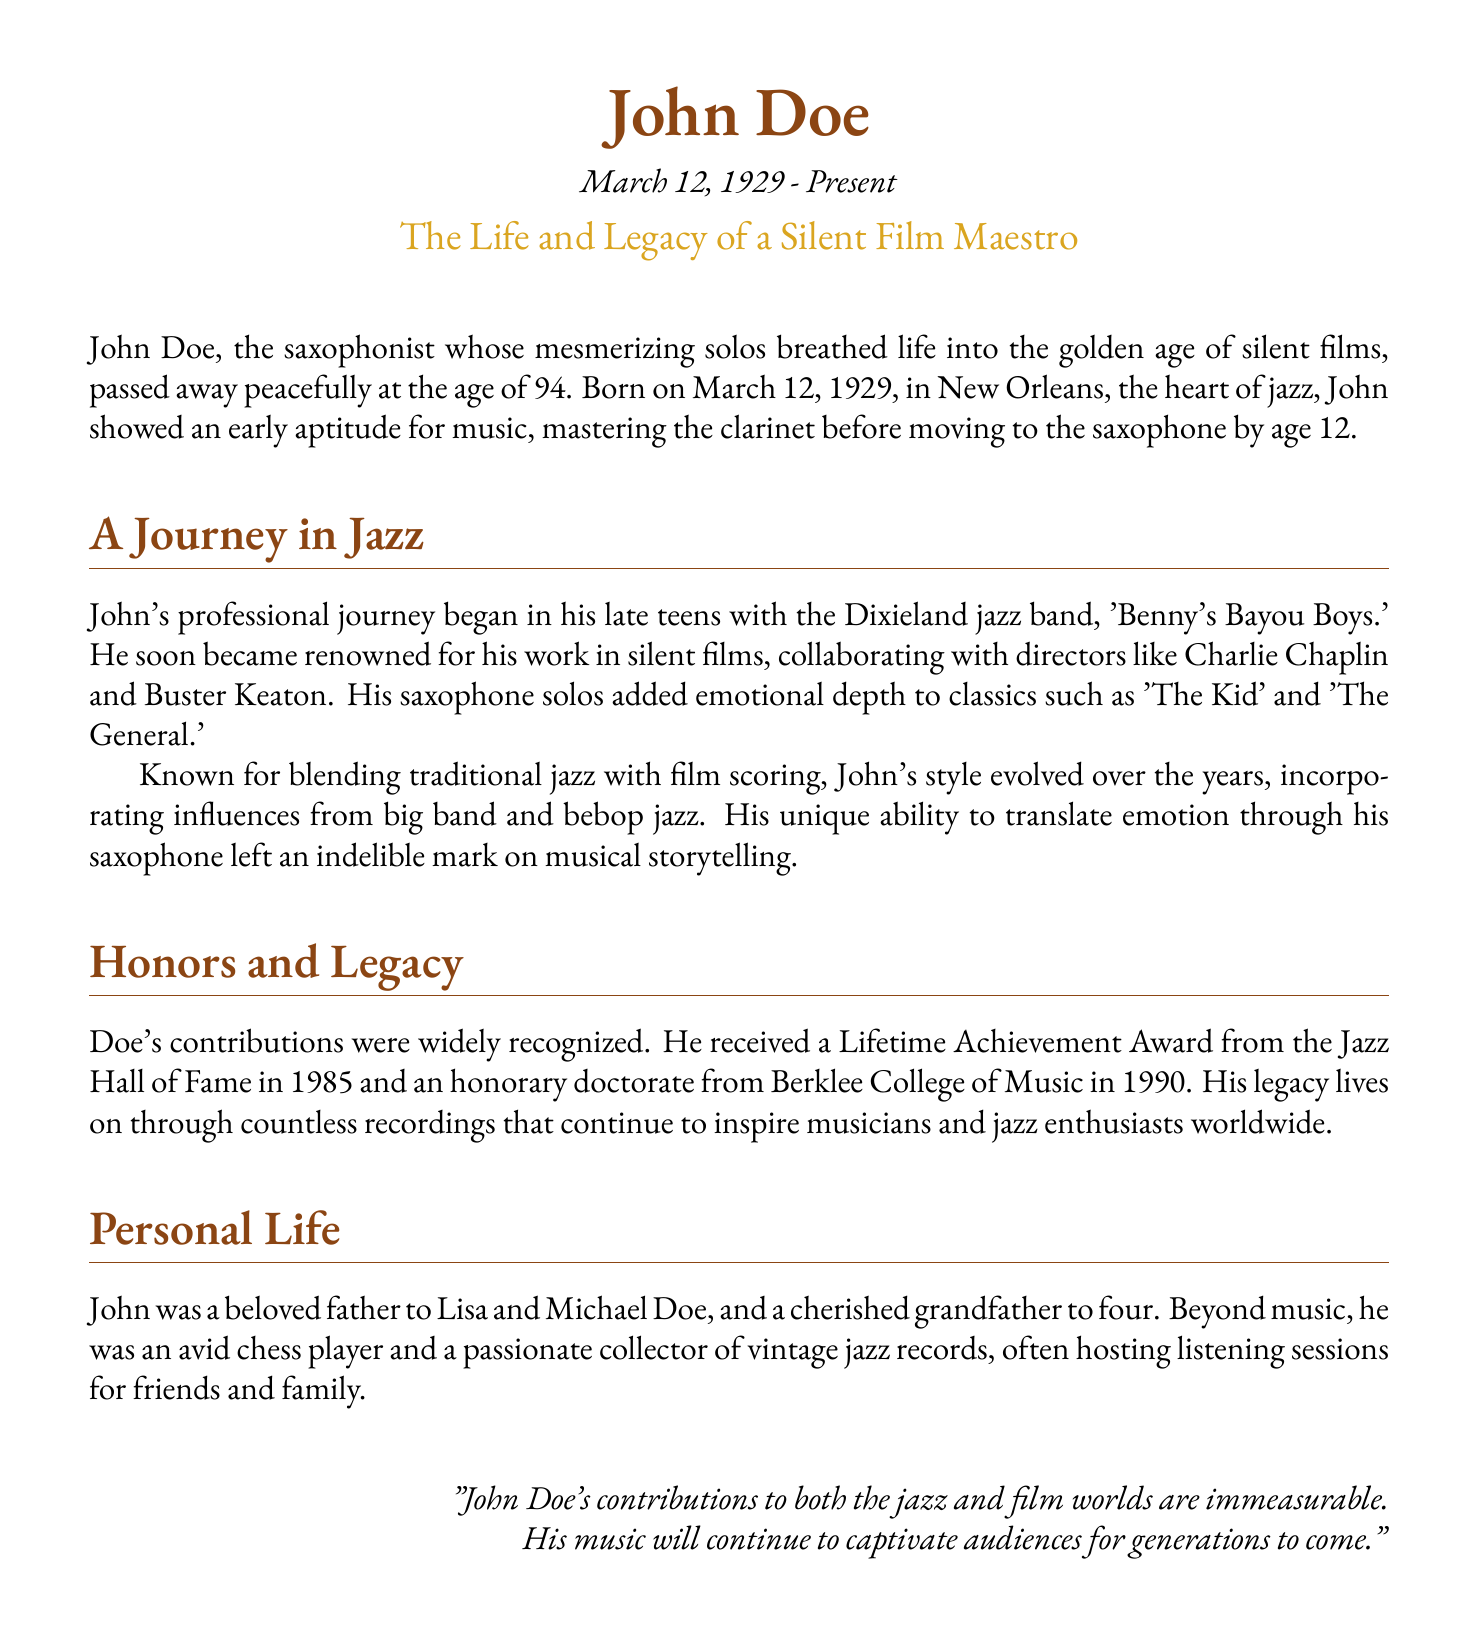what year was John Doe born? The document states that John Doe was born on March 12, 1929.
Answer: 1929 who did John collaborate with in silent films? The document mentions collaborations with directors like Charlie Chaplin and Buster Keaton.
Answer: Charlie Chaplin and Buster Keaton what kind of award did John receive in 1985? The document states that he received a Lifetime Achievement Award from the Jazz Hall of Fame in 1985.
Answer: Lifetime Achievement Award how many children did John have? The document indicates that John was a father to Lisa and Michael Doe.
Answer: Two which instrument did John master before the saxophone? The document states he mastered the clarinet before moving to the saxophone.
Answer: Clarinet what genre did John blend with film scoring? The document mentions blending traditional jazz with film scoring.
Answer: Traditional jazz what was John known for in the silent film era? The document highlights his mesmerizing saxophone solos.
Answer: Mesmerizing saxophone solos how many grandchildren did John have? The document notes that he was a grandfather to four.
Answer: Four 